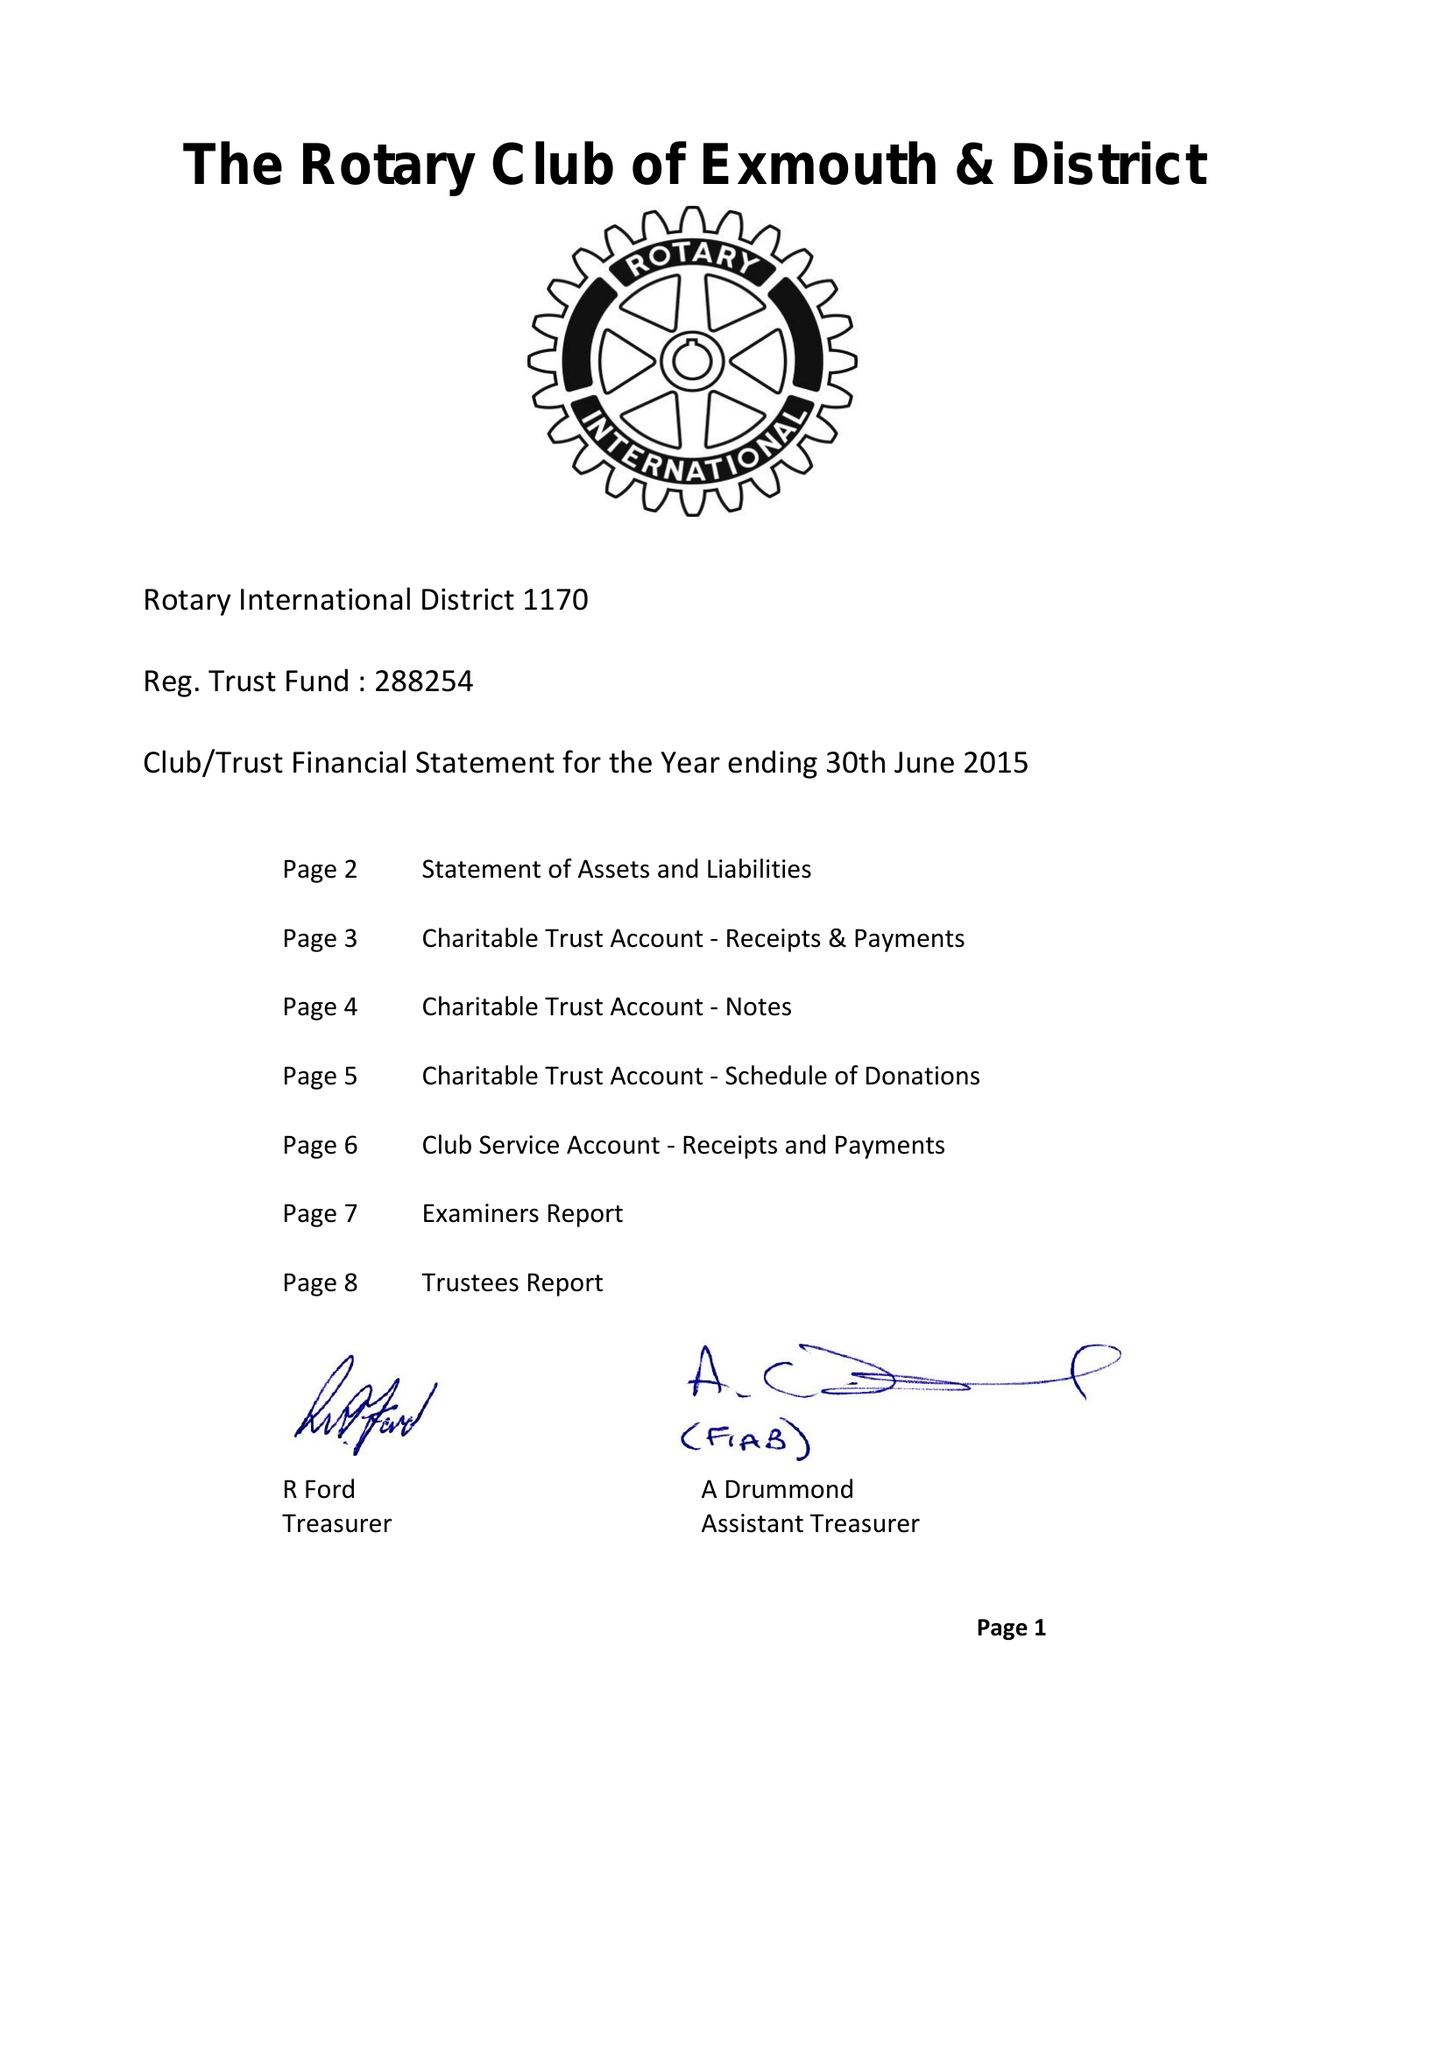What is the value for the address__street_line?
Answer the question using a single word or phrase. 1 BEECHWAY 